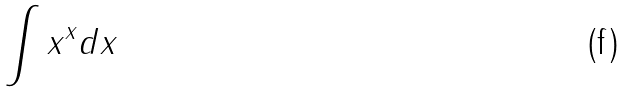Convert formula to latex. <formula><loc_0><loc_0><loc_500><loc_500>\int x ^ { x } d x</formula> 